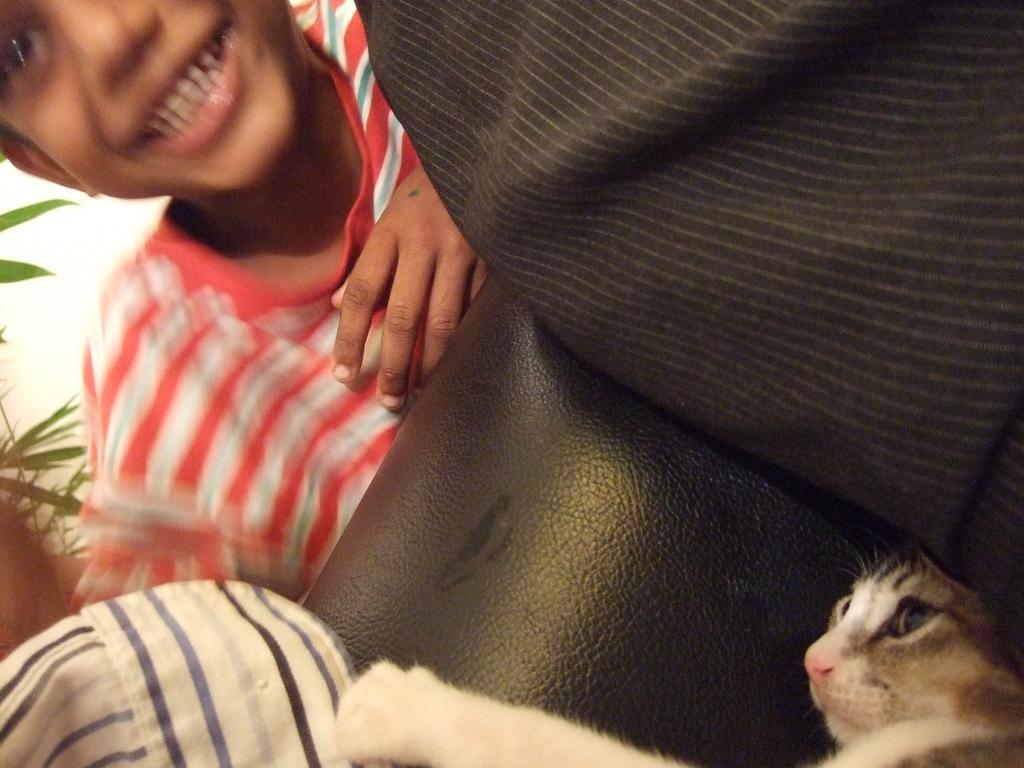What animal is sitting on the sofa in the image? There is a cat on the sofa in the image. Can you describe the child's position in relation to the sofa? The child is behind the sofa in the image. How does the child appear to be feeling in the image? The child is wearing a smile on his face, suggesting he is happy or content. What type of territory is being claimed by the cat in the image? There is no indication in the image that the cat is claiming any territory. What mathematical theory is the child discussing with the cat in the image? There is no discussion of mathematical theories in the image; the child is simply smiling. 